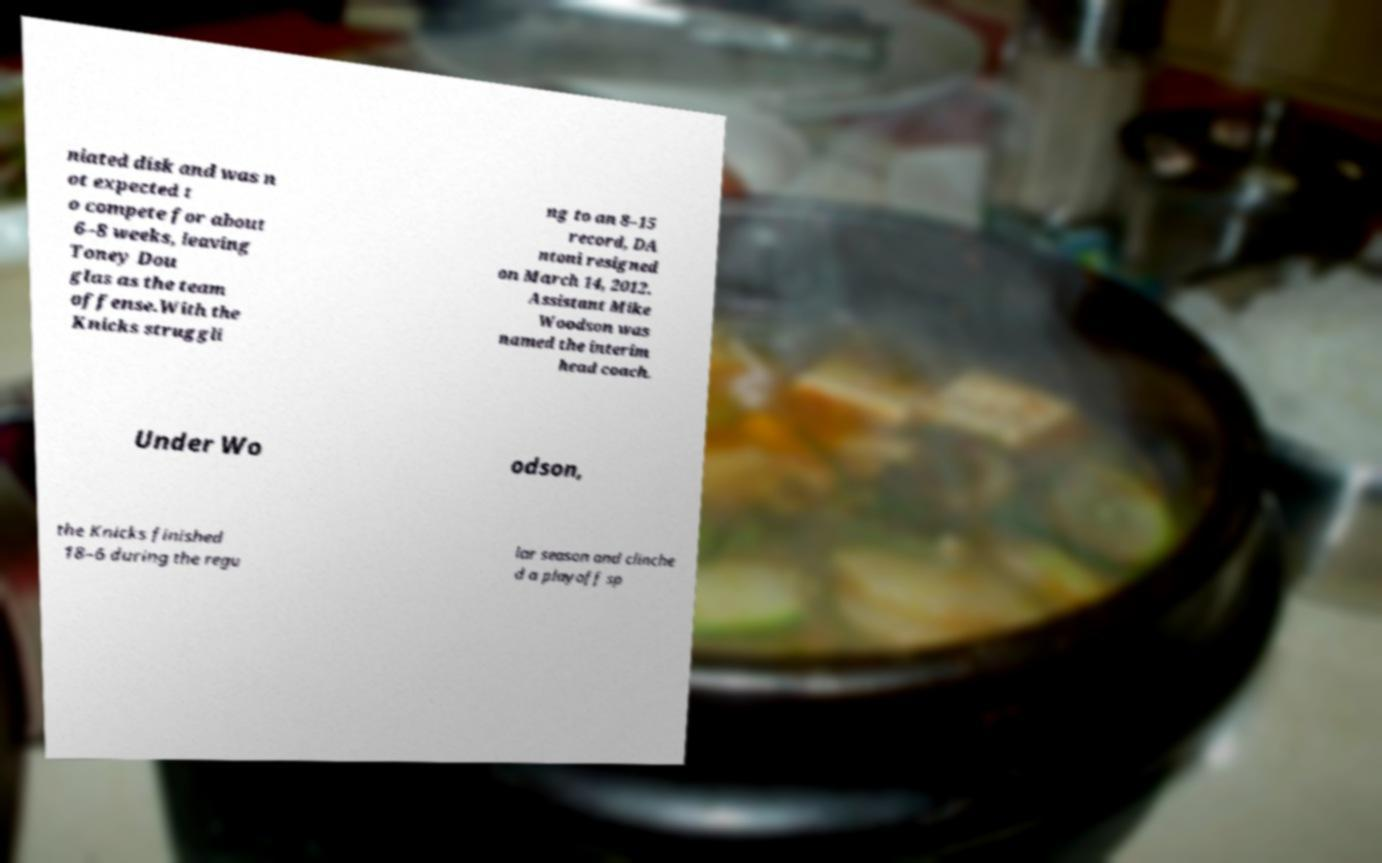What messages or text are displayed in this image? I need them in a readable, typed format. niated disk and was n ot expected t o compete for about 6–8 weeks, leaving Toney Dou glas as the team offense.With the Knicks struggli ng to an 8–15 record, DA ntoni resigned on March 14, 2012. Assistant Mike Woodson was named the interim head coach. Under Wo odson, the Knicks finished 18–6 during the regu lar season and clinche d a playoff sp 